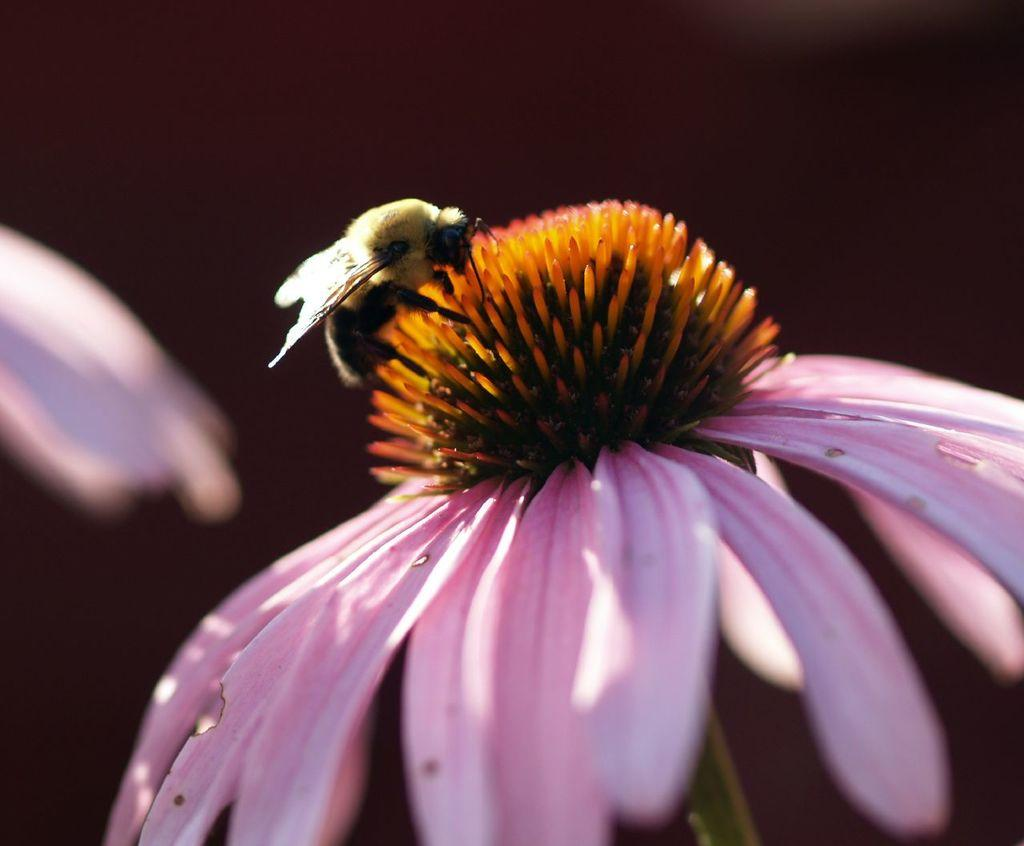What is the main subject of the image? The main subject of the image is an insect. Where is the insect located in the image? The insect is on a flower. What can be observed about the background of the image? The background of the image is dark. What type of metal is the zephyr made of in the image? There is no zephyr or metal present in the image. What is the purpose of the insect in the image? The image does not provide information about the purpose of the insect; it simply shows the insect on a flower. 